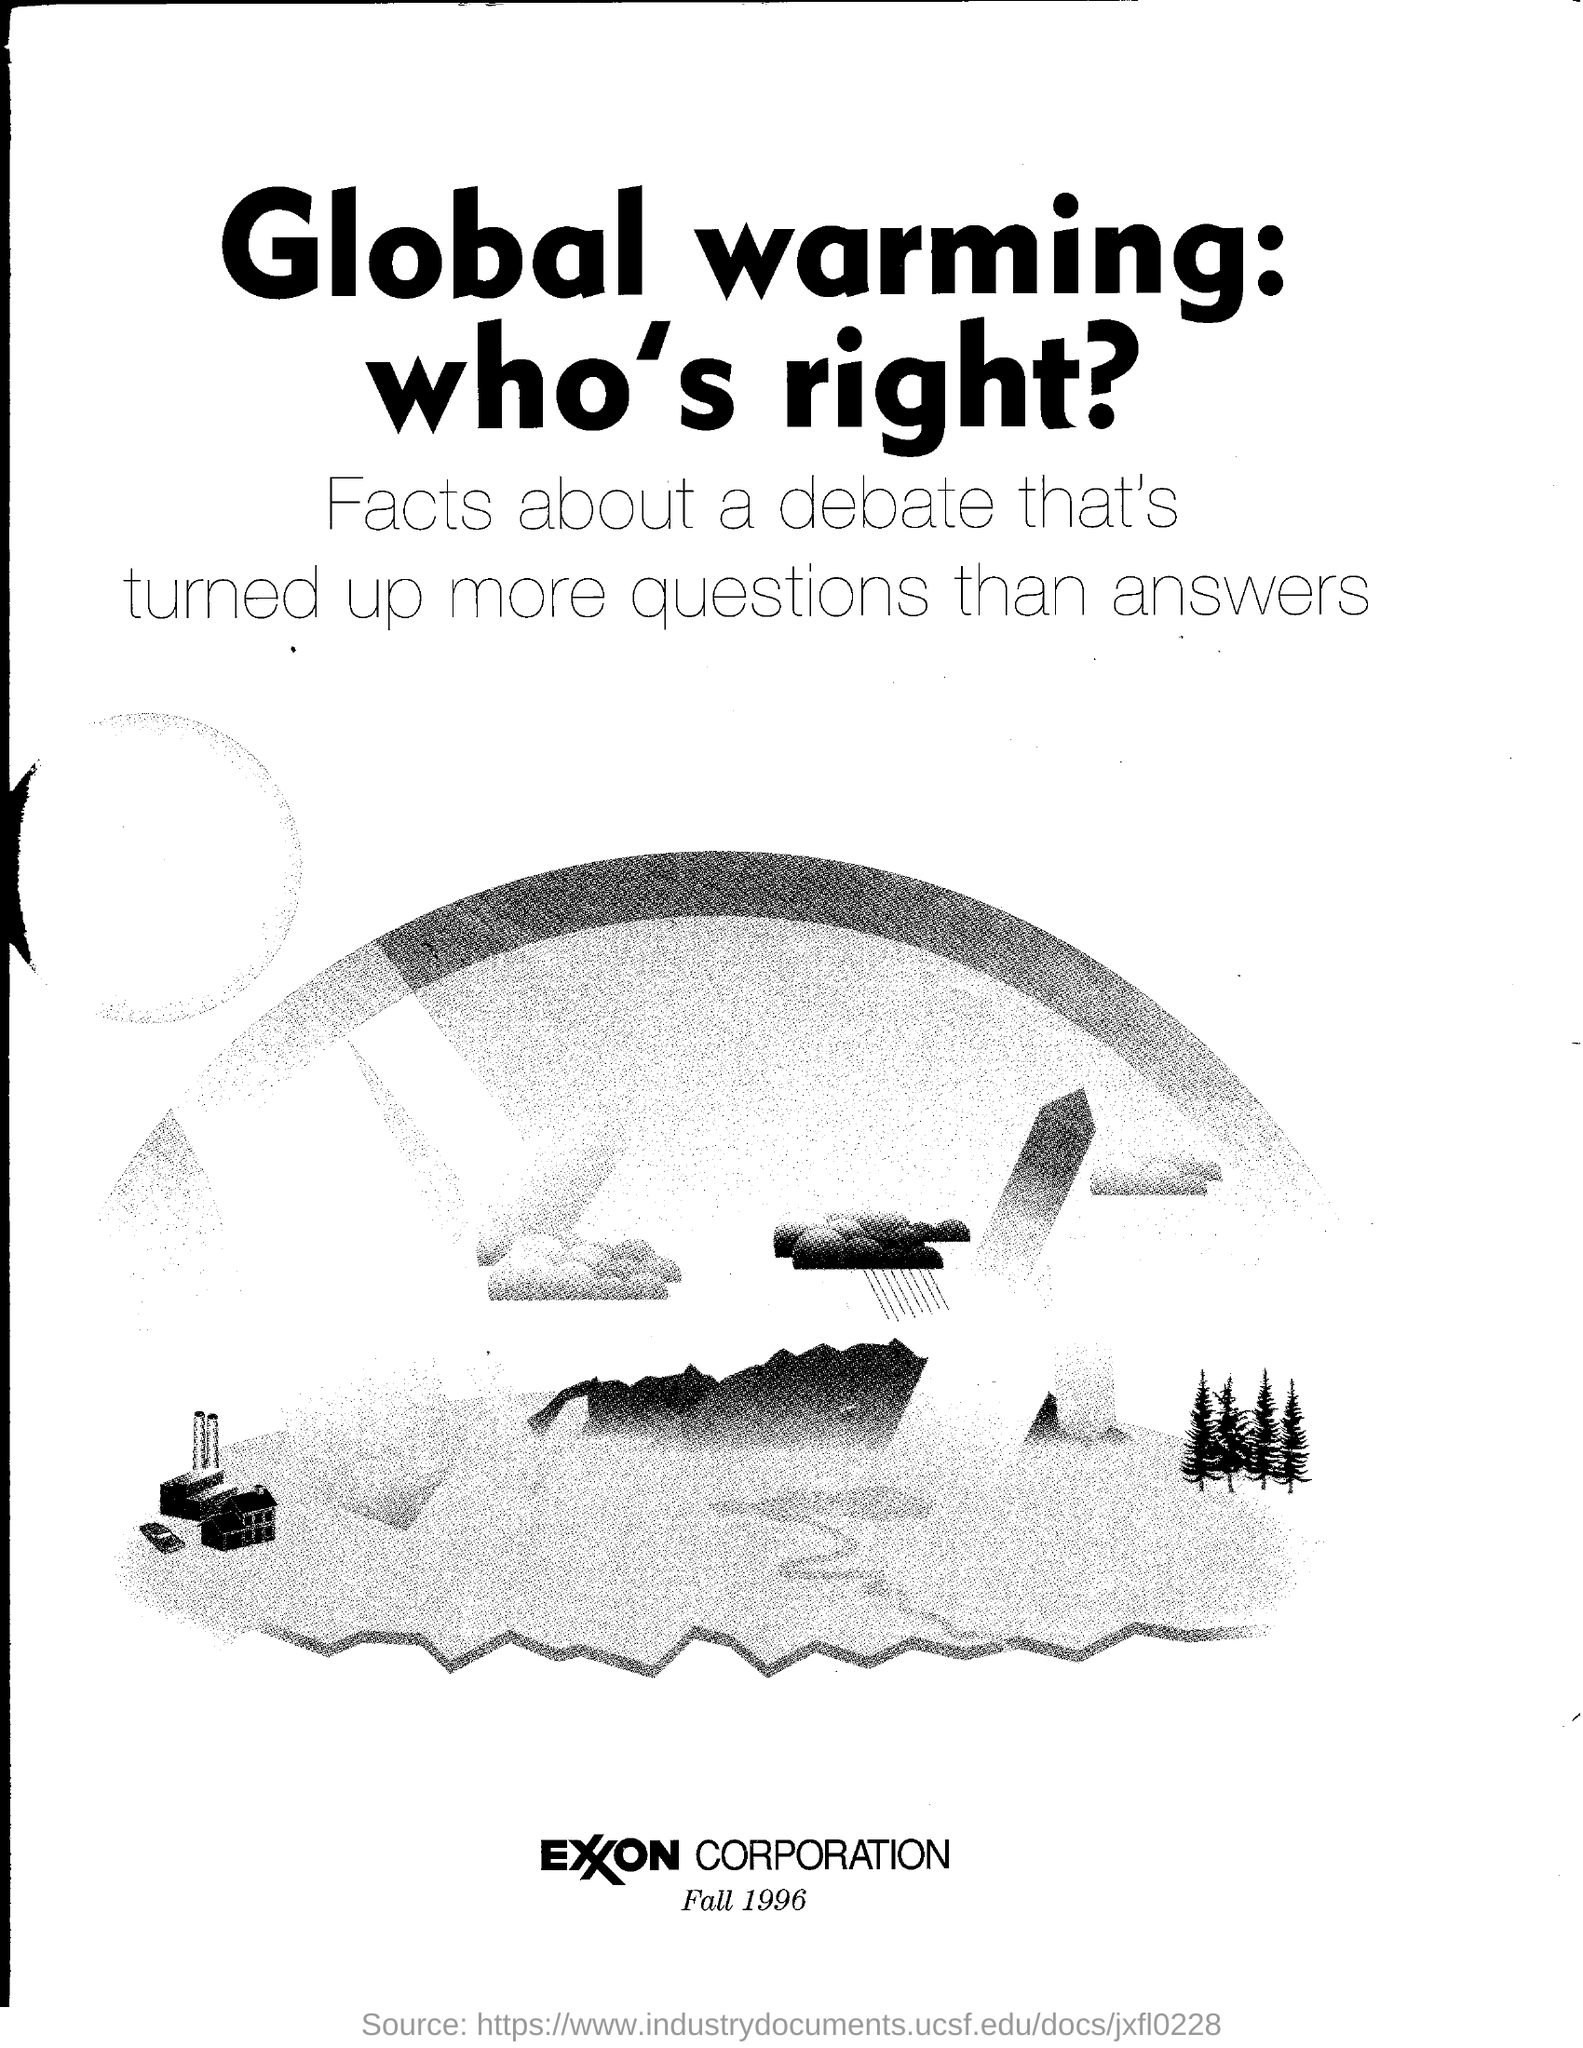Indicate a few pertinent items in this graphic. The year 1996 is given. 